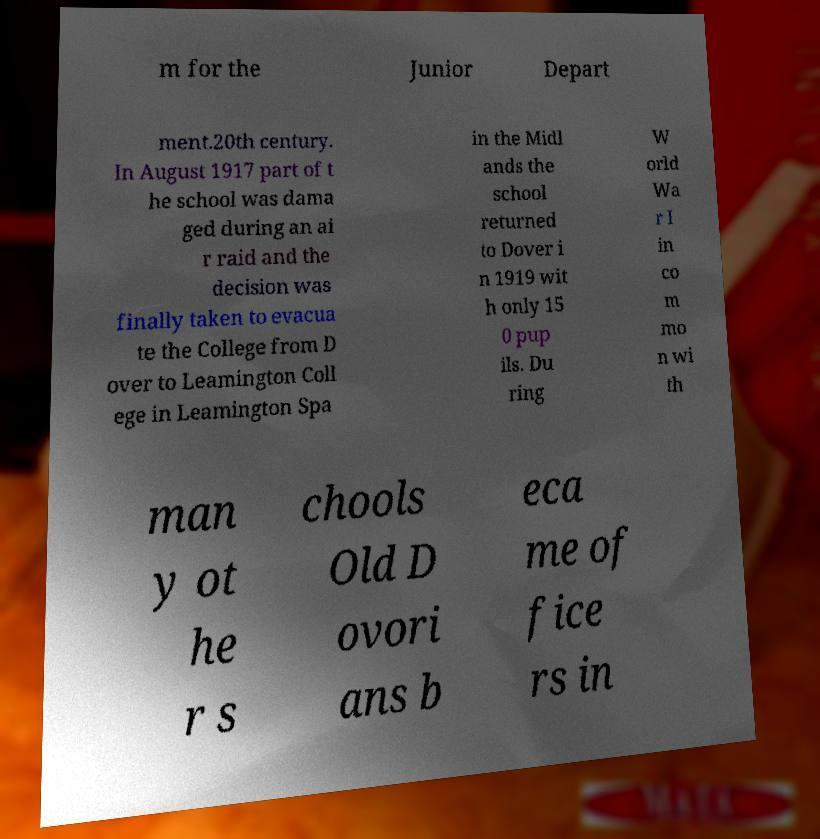Could you assist in decoding the text presented in this image and type it out clearly? m for the Junior Depart ment.20th century. In August 1917 part of t he school was dama ged during an ai r raid and the decision was finally taken to evacua te the College from D over to Leamington Coll ege in Leamington Spa in the Midl ands the school returned to Dover i n 1919 wit h only 15 0 pup ils. Du ring W orld Wa r I in co m mo n wi th man y ot he r s chools Old D ovori ans b eca me of fice rs in 